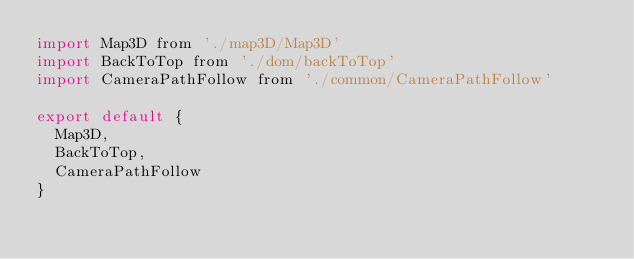<code> <loc_0><loc_0><loc_500><loc_500><_JavaScript_>import Map3D from './map3D/Map3D'
import BackToTop from './dom/backToTop'
import CameraPathFollow from './common/CameraPathFollow'

export default {
  Map3D,
  BackToTop,
  CameraPathFollow
}
</code> 